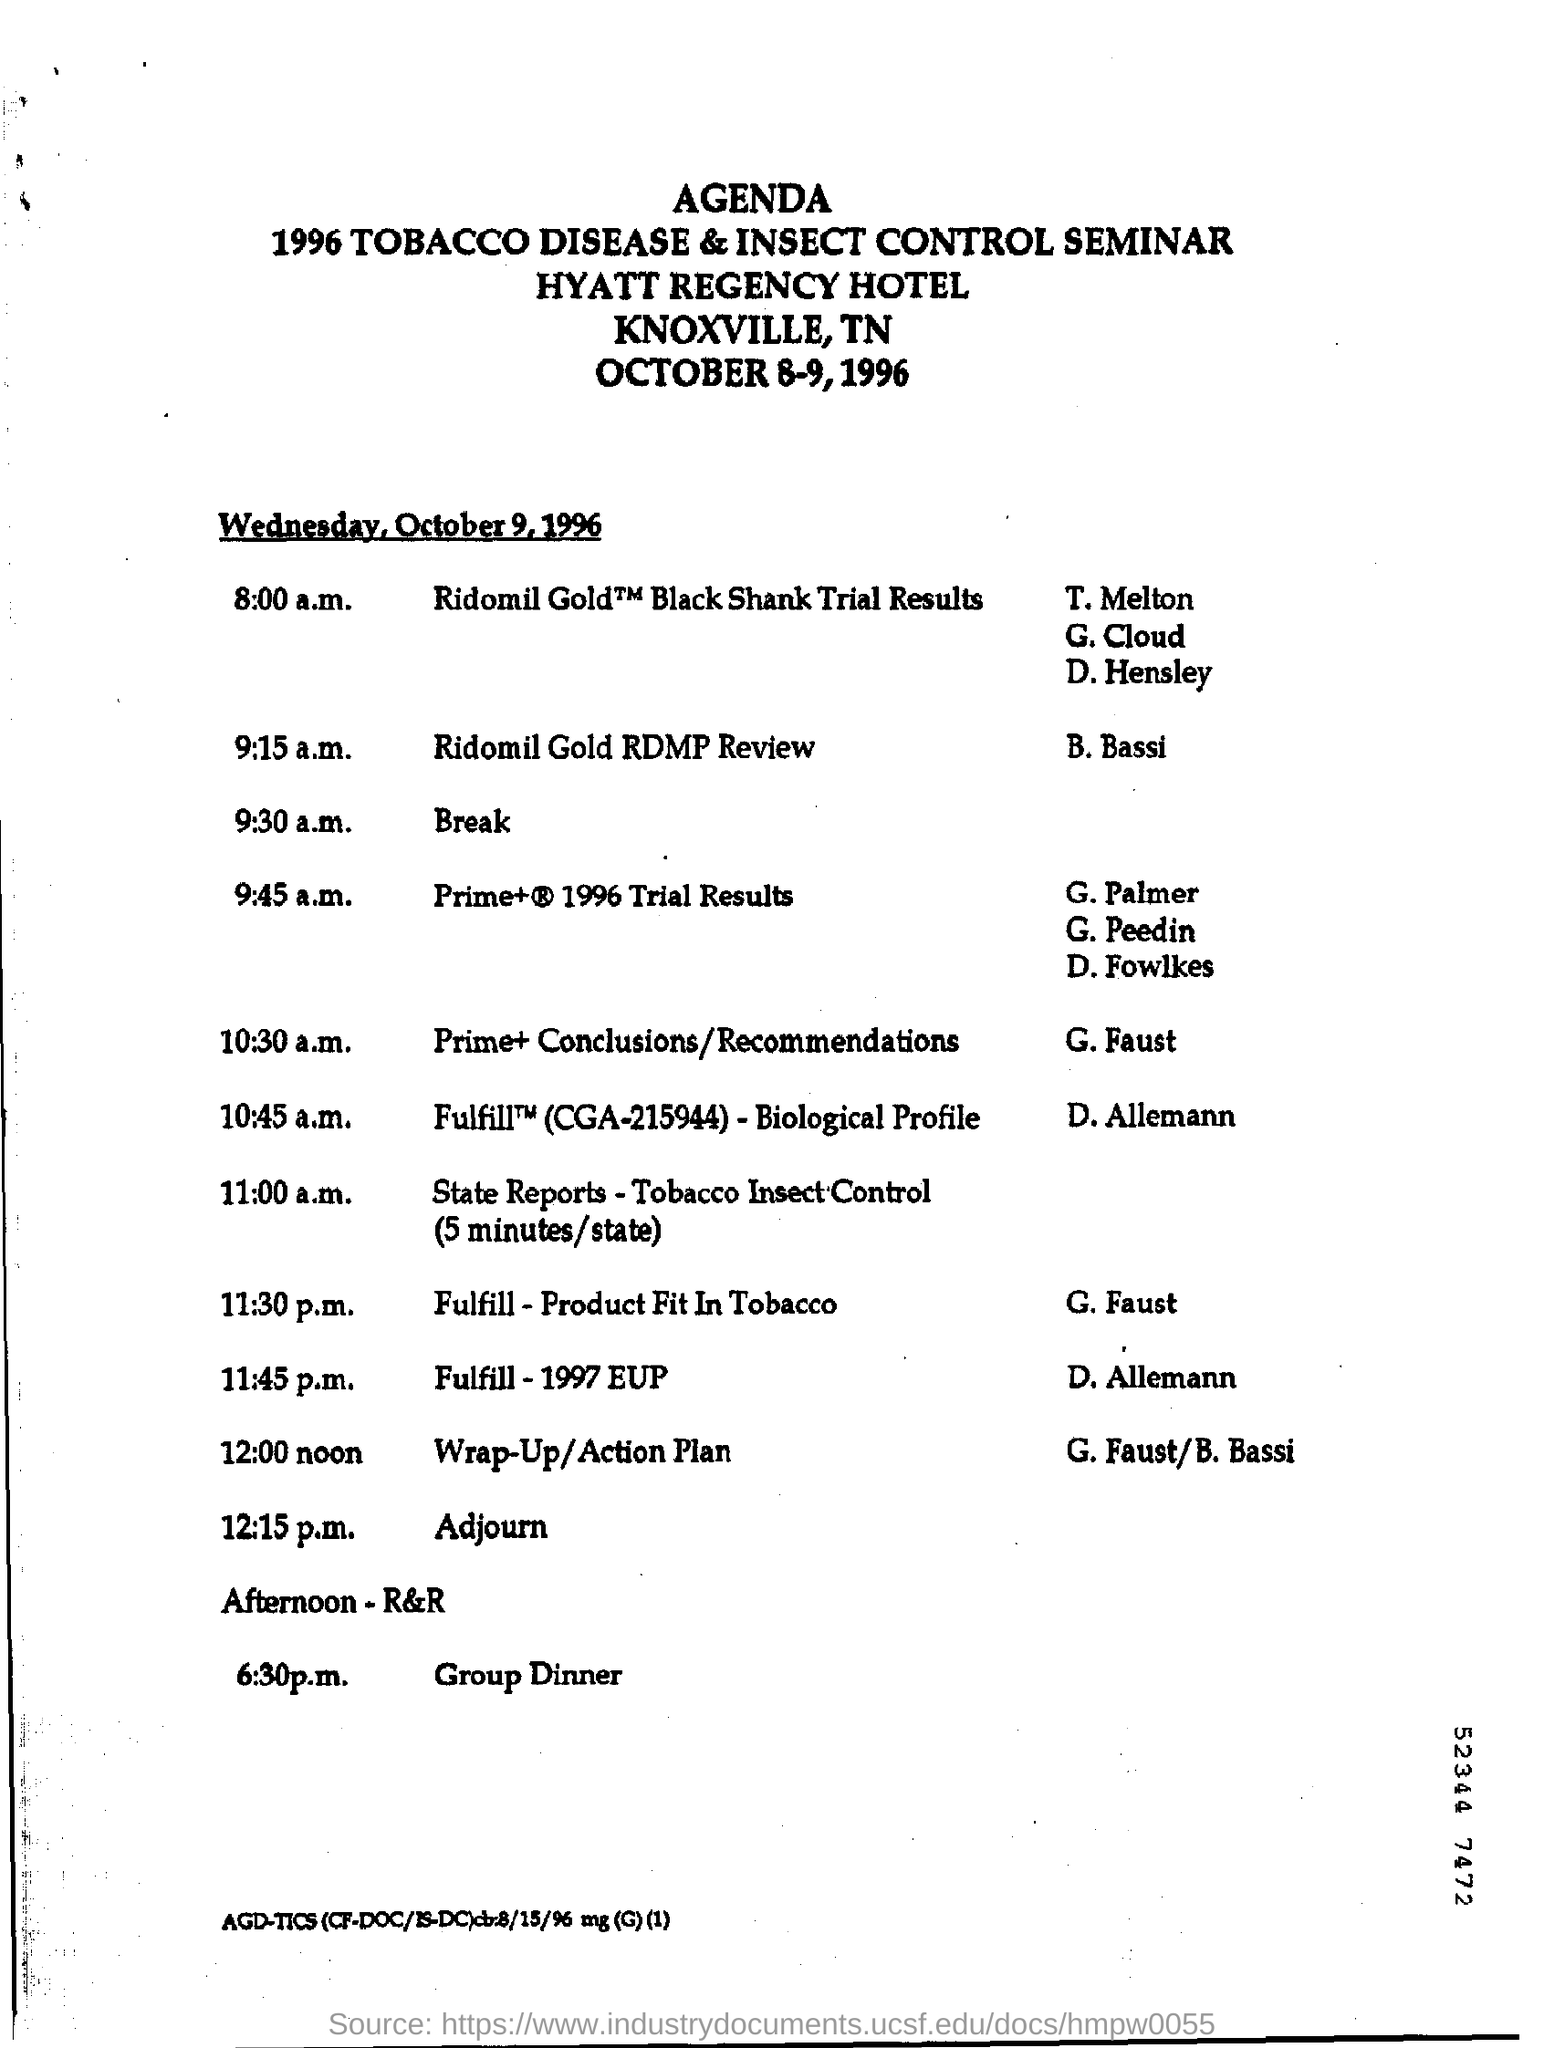Outline some significant characteristics in this image. The time of the break for the 1996 Tobacco Disease & Insect Control seminar is 9:30 a.m. 